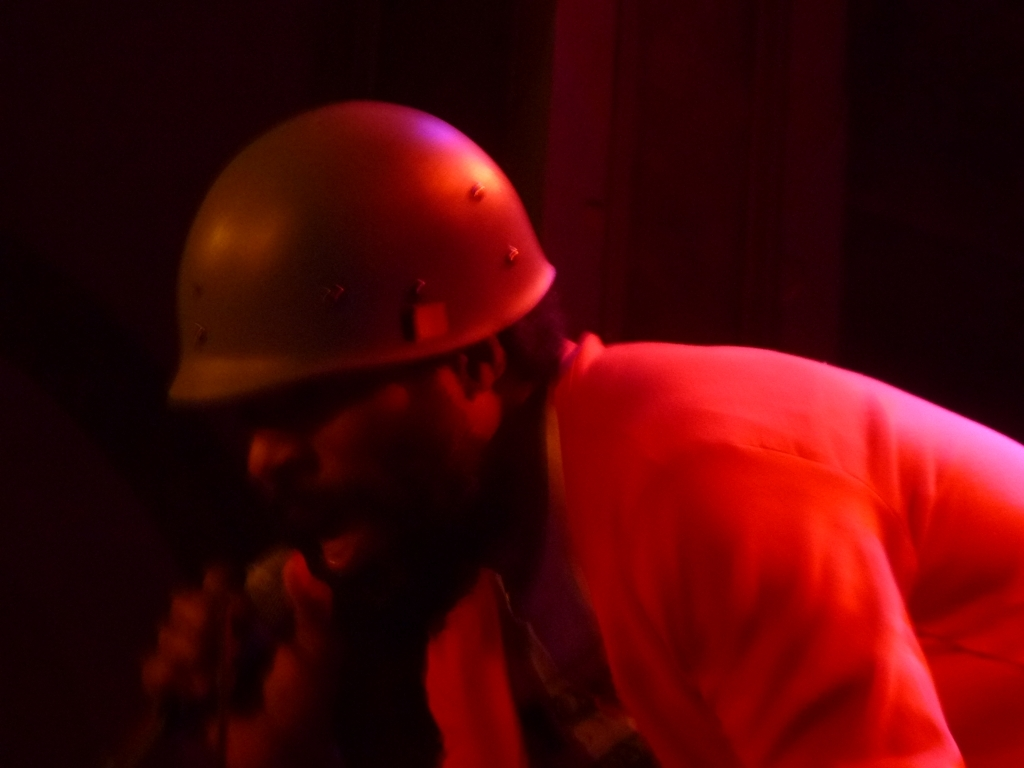Can you describe the setting and attire of the subject in this image? The subject is wearing what seems to be a protective helmet and is dressed in a bright orange shirt, suggesting a setting that may require safety gear. This could indicate an industrial environment or a performance where protective headgear is a part of the attire. The darkness in the background prevents a clear view of the setting, but the focus is clearly on the man, who could be engaged in work or performance art. 